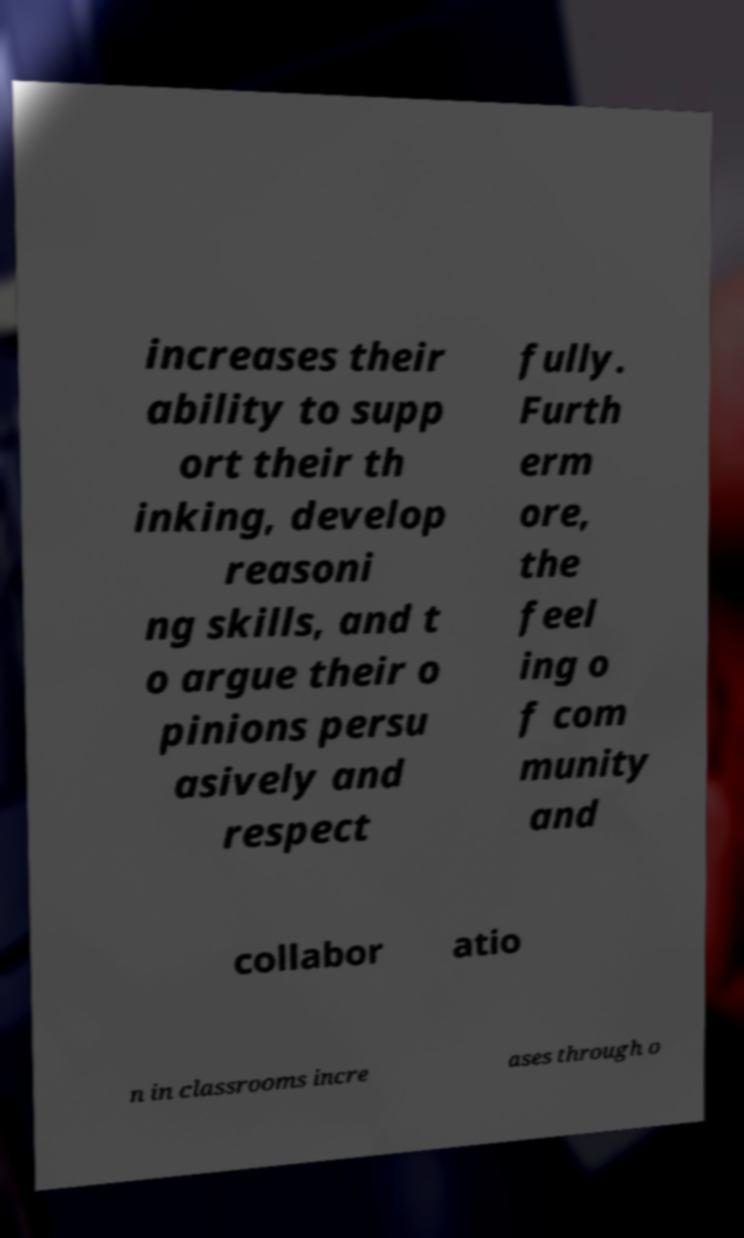For documentation purposes, I need the text within this image transcribed. Could you provide that? increases their ability to supp ort their th inking, develop reasoni ng skills, and t o argue their o pinions persu asively and respect fully. Furth erm ore, the feel ing o f com munity and collabor atio n in classrooms incre ases through o 